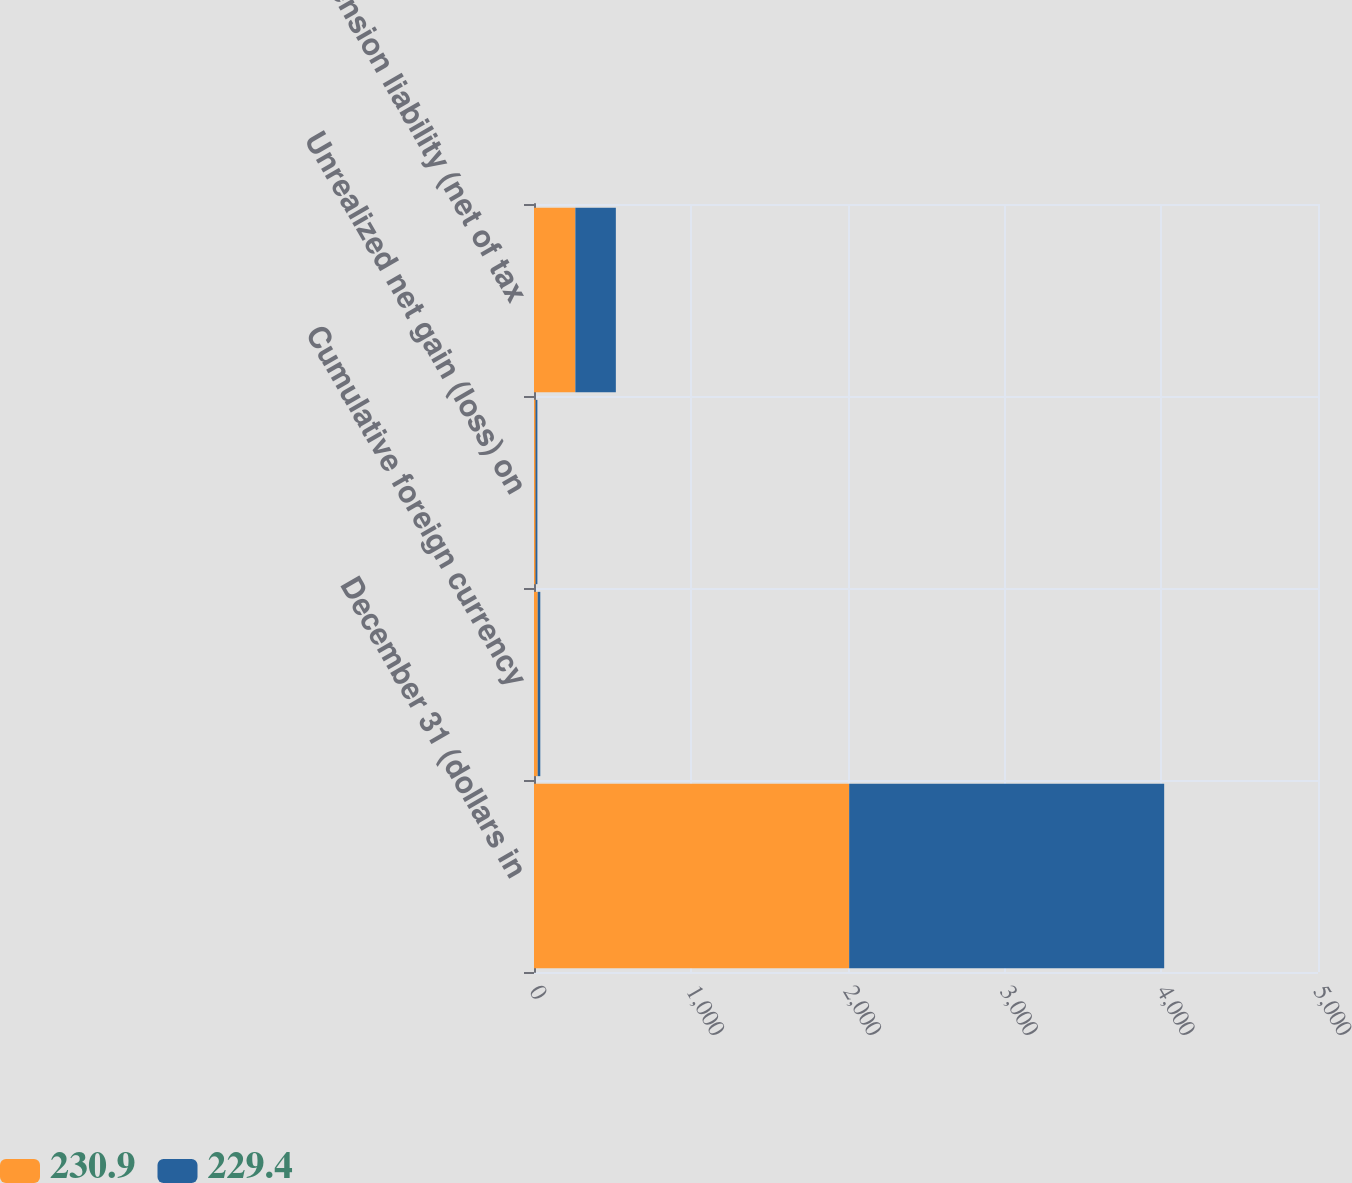<chart> <loc_0><loc_0><loc_500><loc_500><stacked_bar_chart><ecel><fcel>December 31 (dollars in<fcel>Cumulative foreign currency<fcel>Unrealized net gain (loss) on<fcel>Pension liability (net of tax<nl><fcel>230.9<fcel>2010<fcel>23.7<fcel>10.7<fcel>263.8<nl><fcel>229.4<fcel>2009<fcel>16.4<fcel>10.9<fcel>258.2<nl></chart> 